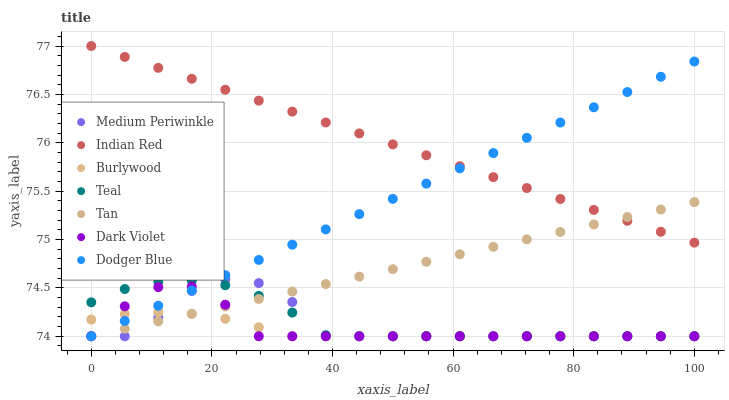Does Burlywood have the minimum area under the curve?
Answer yes or no. Yes. Does Indian Red have the maximum area under the curve?
Answer yes or no. Yes. Does Medium Periwinkle have the minimum area under the curve?
Answer yes or no. No. Does Medium Periwinkle have the maximum area under the curve?
Answer yes or no. No. Is Tan the smoothest?
Answer yes or no. Yes. Is Medium Periwinkle the roughest?
Answer yes or no. Yes. Is Burlywood the smoothest?
Answer yes or no. No. Is Burlywood the roughest?
Answer yes or no. No. Does Burlywood have the lowest value?
Answer yes or no. Yes. Does Indian Red have the highest value?
Answer yes or no. Yes. Does Medium Periwinkle have the highest value?
Answer yes or no. No. Is Burlywood less than Indian Red?
Answer yes or no. Yes. Is Indian Red greater than Medium Periwinkle?
Answer yes or no. Yes. Does Medium Periwinkle intersect Burlywood?
Answer yes or no. Yes. Is Medium Periwinkle less than Burlywood?
Answer yes or no. No. Is Medium Periwinkle greater than Burlywood?
Answer yes or no. No. Does Burlywood intersect Indian Red?
Answer yes or no. No. 